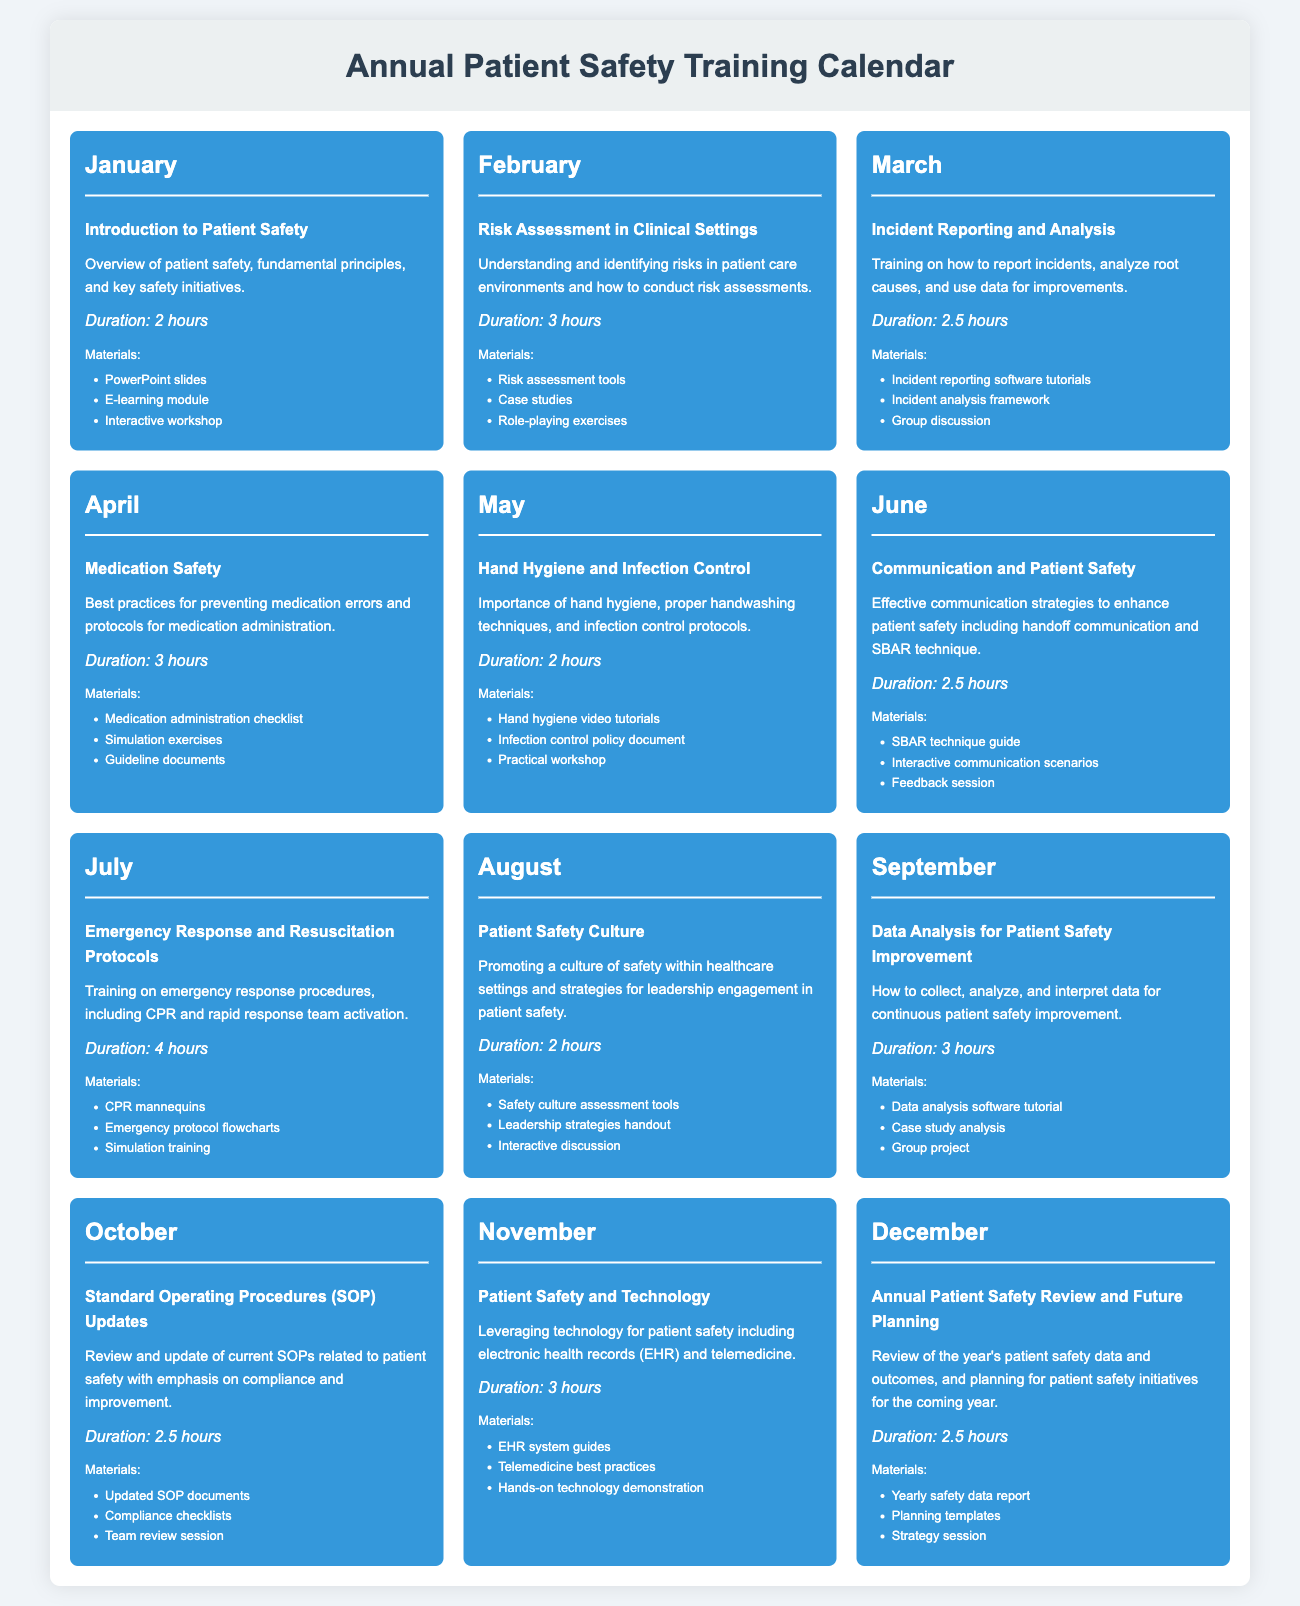what topic is covered in March? The document lists "Incident Reporting and Analysis" as the training topic for March.
Answer: Incident Reporting and Analysis how long is the training session on Medication Safety? The duration for the Medication Safety training session is specified in the document.
Answer: 3 hours which month features training on Data Analysis for Patient Safety Improvement? The specific month for this training can be found in the calendar section of the document.
Answer: September what materials are provided for the training in August? The document outlines the materials for the Patient Safety Culture training in August.
Answer: Safety culture assessment tools, Leadership strategies handout, Interactive discussion how many hours is the Annual Patient Safety Review training? The training duration for the December session is stated within the document.
Answer: 2.5 hours what is the main focus of the training in June? The details for the June training session describe its focus.
Answer: Effective communication strategies to enhance patient safety how many different topics are covered throughout the year? By counting the topics listed in the monthly sections, we determine the total.
Answer: 12 topics what is the duration of the training in July? The duration for the Emergency Response and Resuscitation Protocols training is specified.
Answer: 4 hours what type of materials are used in the February training session? The document lists the specific materials used for February's training session.
Answer: Risk assessment tools, Case studies, Role-playing exercises 